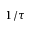<formula> <loc_0><loc_0><loc_500><loc_500>1 / \tau</formula> 